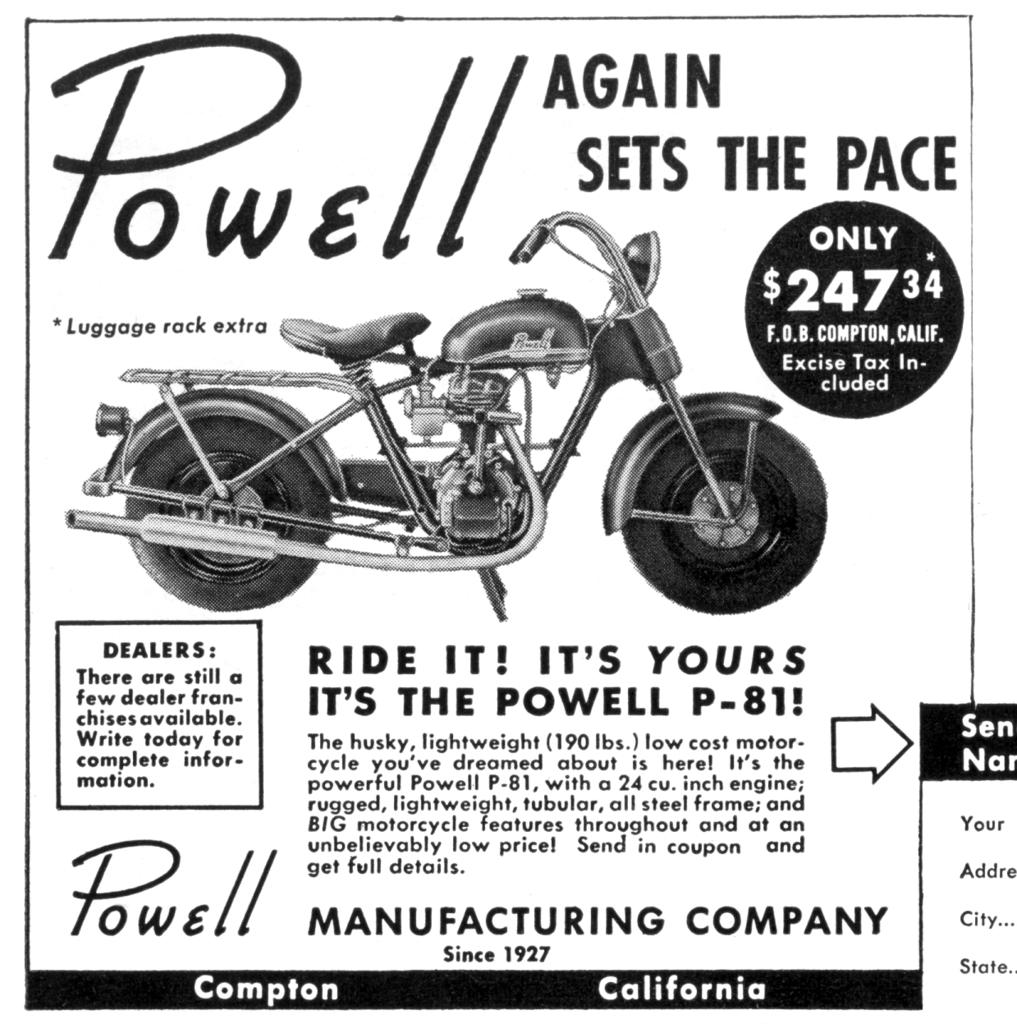What type of image is depicted in the poster? The image is a poster featuring a picture of a motorbike. What else can be seen on the poster besides the motorbike? There are letters on the poster. Can you tell me how many combs are depicted on the poster? There are no combs present on the poster; it features a picture of a motorbike and letters. Is there any snow visible on the motorbike in the poster? There is no snow present on the motorbike or in the poster; it is a picture of a motorbike without any snow. 